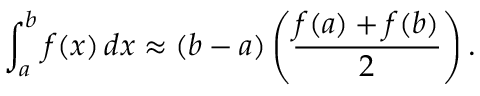<formula> <loc_0><loc_0><loc_500><loc_500>\int _ { a } ^ { b } f ( x ) \, d x \approx ( b - a ) \left ( { \frac { f ( a ) + f ( b ) } { 2 } } \right ) .</formula> 